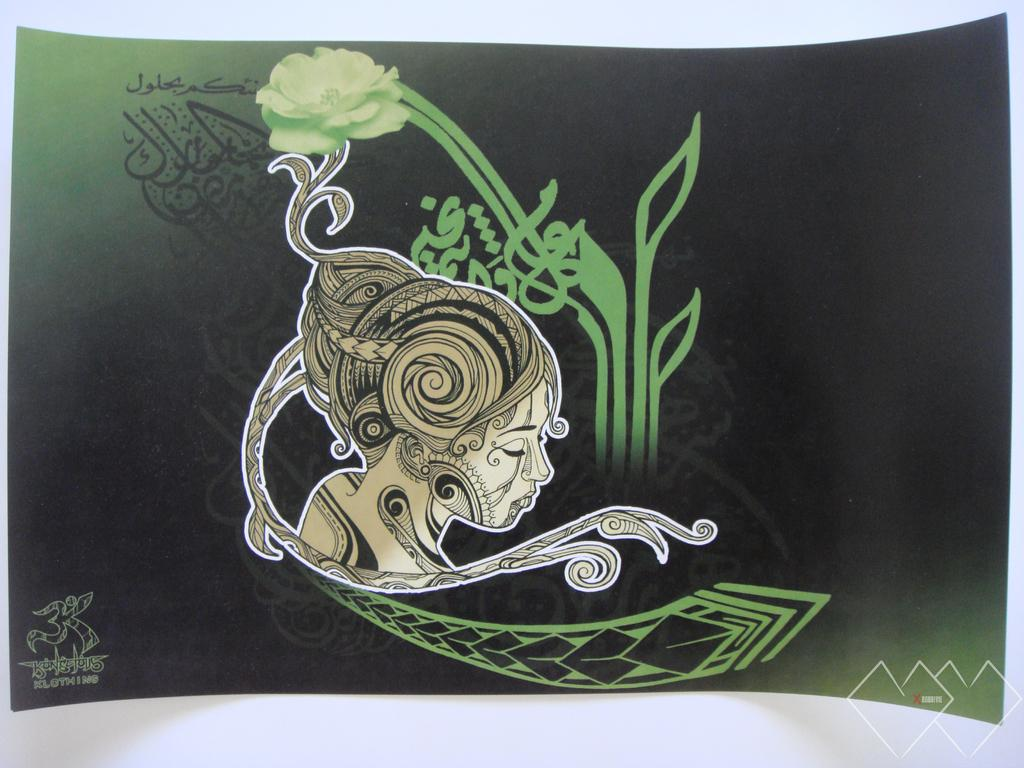What is the main subject of the image? There is a person's face in the image. Are there any other objects or elements in the image besides the person's face? Yes, there is a flower and a design in the image. How much money is being exchanged in the image? There is no money present in the image; it features a person's face, a flower, and a design. 